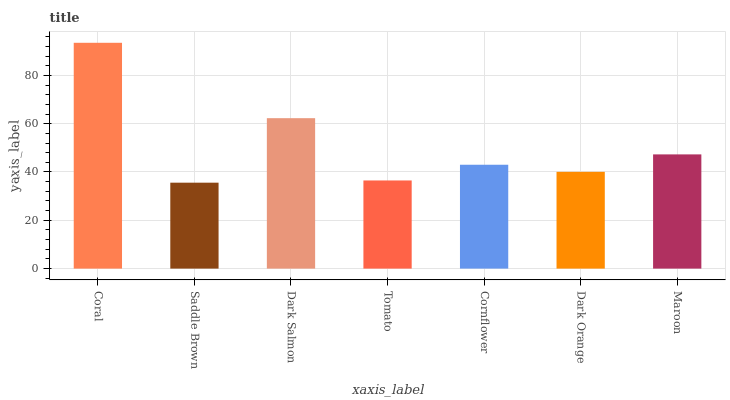Is Saddle Brown the minimum?
Answer yes or no. Yes. Is Coral the maximum?
Answer yes or no. Yes. Is Dark Salmon the minimum?
Answer yes or no. No. Is Dark Salmon the maximum?
Answer yes or no. No. Is Dark Salmon greater than Saddle Brown?
Answer yes or no. Yes. Is Saddle Brown less than Dark Salmon?
Answer yes or no. Yes. Is Saddle Brown greater than Dark Salmon?
Answer yes or no. No. Is Dark Salmon less than Saddle Brown?
Answer yes or no. No. Is Cornflower the high median?
Answer yes or no. Yes. Is Cornflower the low median?
Answer yes or no. Yes. Is Dark Salmon the high median?
Answer yes or no. No. Is Maroon the low median?
Answer yes or no. No. 